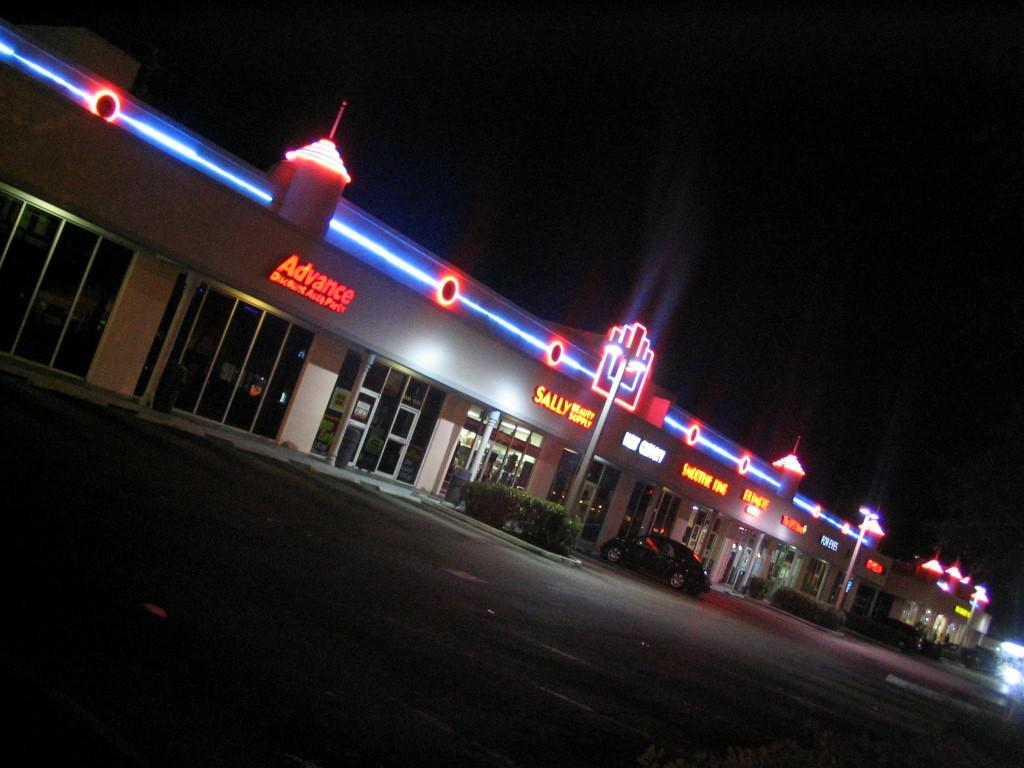What type of structures can be seen in the image? There are buildings in the image. What can be seen illuminating the scene in the image? There are lights visible in the image. What type of advertisements or signs are present in the image? There are hoardings in the image. What type of vertical structures can be seen in the image? There are poles in the image. What type of vehicle is parked in front of a building in the image? There is a car in front of a building in the image. How would you describe the lighting conditions in the background of the image? The background of the image is dark. What type of shade is provided by the string in the image? There is no string present in the image, so no shade is provided by it. What is the purpose of the buildings in the image? The purpose of the buildings in the image cannot be determined from the image alone. 